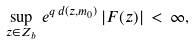<formula> <loc_0><loc_0><loc_500><loc_500>\sup _ { z \in Z _ { b } } \, e ^ { q \, d ( z , m _ { 0 } ) } \, | F ( z ) | \, < \, \infty ,</formula> 